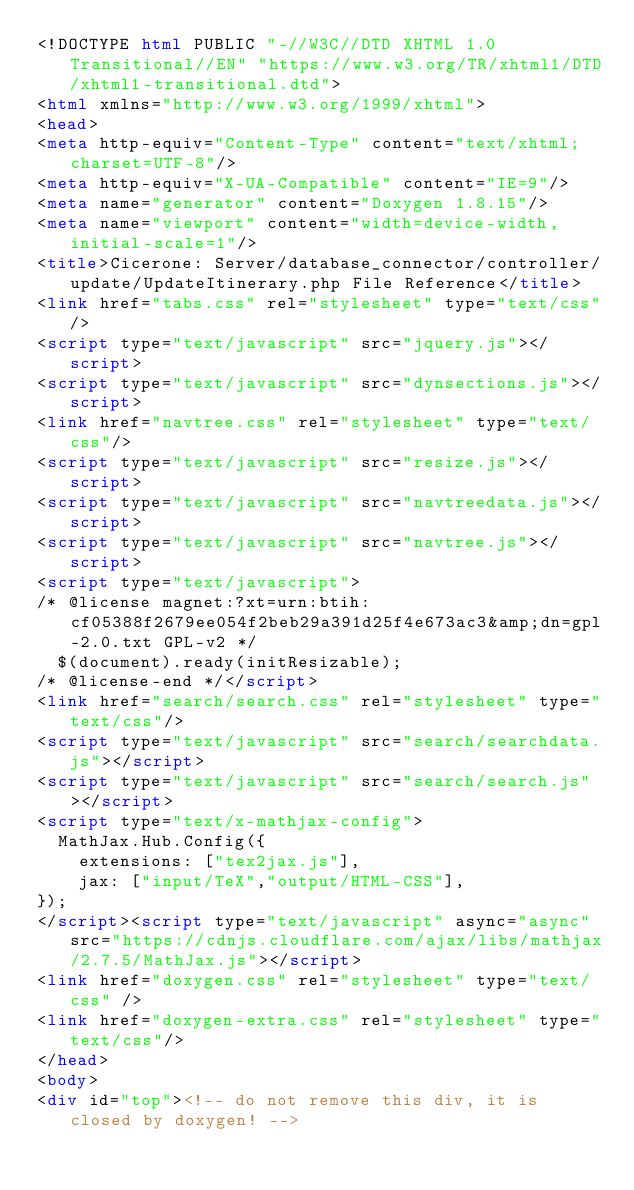Convert code to text. <code><loc_0><loc_0><loc_500><loc_500><_HTML_><!DOCTYPE html PUBLIC "-//W3C//DTD XHTML 1.0 Transitional//EN" "https://www.w3.org/TR/xhtml1/DTD/xhtml1-transitional.dtd">
<html xmlns="http://www.w3.org/1999/xhtml">
<head>
<meta http-equiv="Content-Type" content="text/xhtml;charset=UTF-8"/>
<meta http-equiv="X-UA-Compatible" content="IE=9"/>
<meta name="generator" content="Doxygen 1.8.15"/>
<meta name="viewport" content="width=device-width, initial-scale=1"/>
<title>Cicerone: Server/database_connector/controller/update/UpdateItinerary.php File Reference</title>
<link href="tabs.css" rel="stylesheet" type="text/css"/>
<script type="text/javascript" src="jquery.js"></script>
<script type="text/javascript" src="dynsections.js"></script>
<link href="navtree.css" rel="stylesheet" type="text/css"/>
<script type="text/javascript" src="resize.js"></script>
<script type="text/javascript" src="navtreedata.js"></script>
<script type="text/javascript" src="navtree.js"></script>
<script type="text/javascript">
/* @license magnet:?xt=urn:btih:cf05388f2679ee054f2beb29a391d25f4e673ac3&amp;dn=gpl-2.0.txt GPL-v2 */
  $(document).ready(initResizable);
/* @license-end */</script>
<link href="search/search.css" rel="stylesheet" type="text/css"/>
<script type="text/javascript" src="search/searchdata.js"></script>
<script type="text/javascript" src="search/search.js"></script>
<script type="text/x-mathjax-config">
  MathJax.Hub.Config({
    extensions: ["tex2jax.js"],
    jax: ["input/TeX","output/HTML-CSS"],
});
</script><script type="text/javascript" async="async" src="https://cdnjs.cloudflare.com/ajax/libs/mathjax/2.7.5/MathJax.js"></script>
<link href="doxygen.css" rel="stylesheet" type="text/css" />
<link href="doxygen-extra.css" rel="stylesheet" type="text/css"/>
</head>
<body>
<div id="top"><!-- do not remove this div, it is closed by doxygen! --></code> 